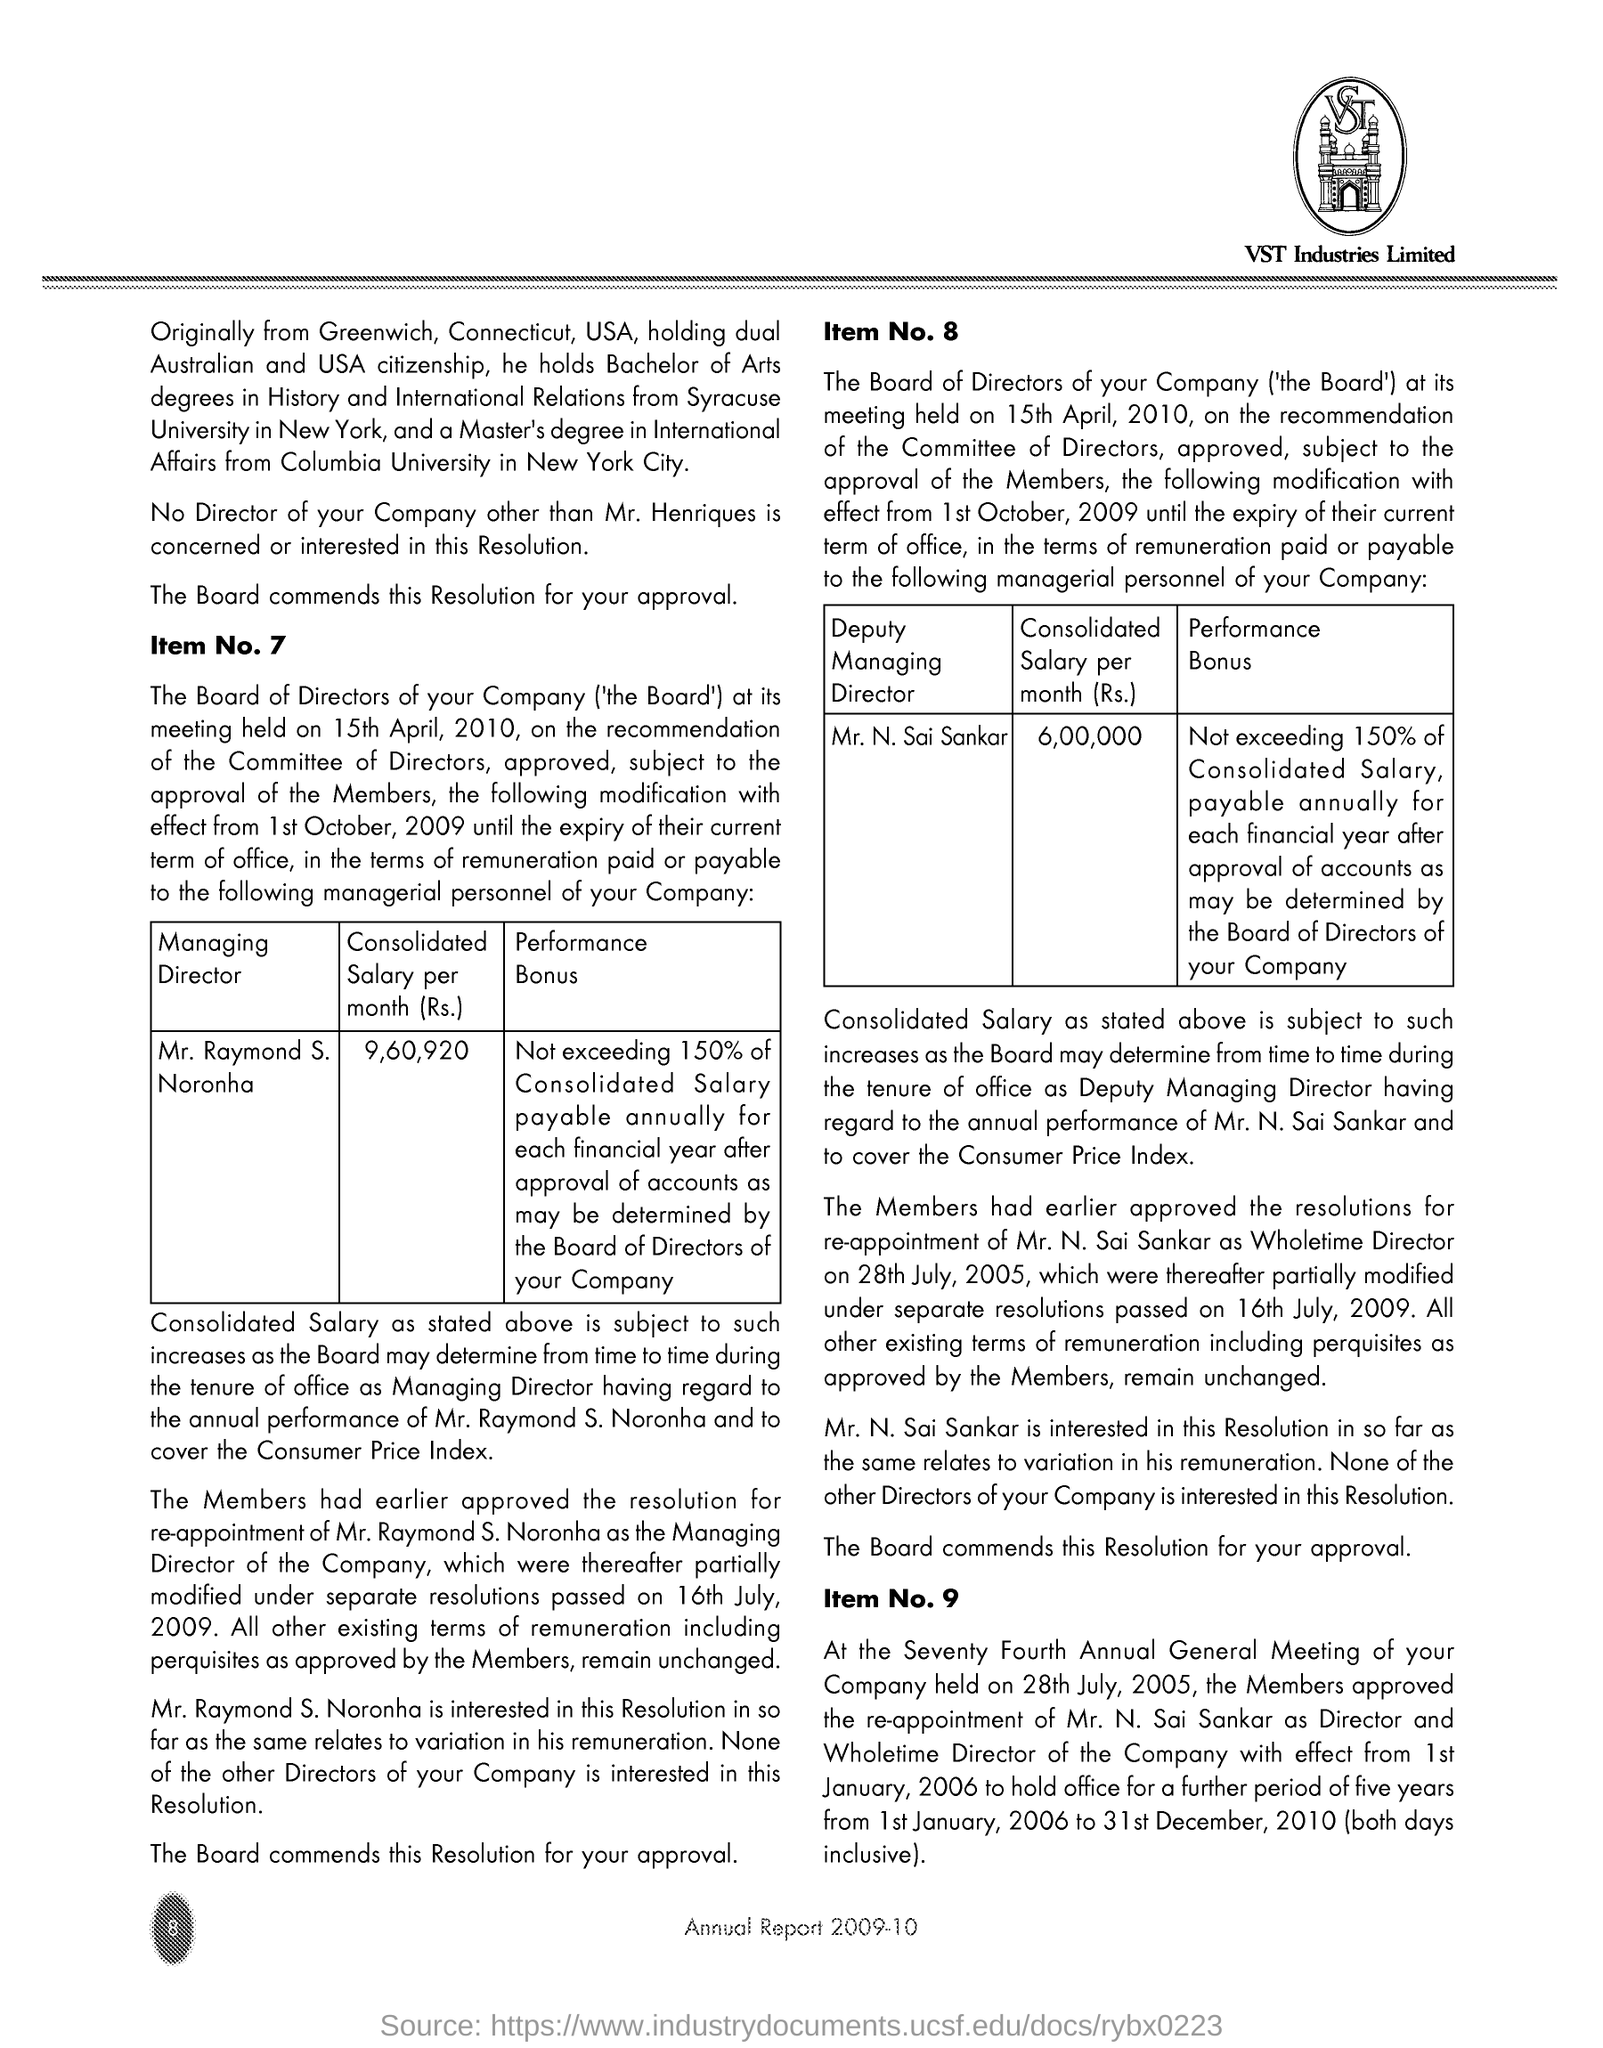What is the consolidated salary of Mr. Raymond S Norantha?
Offer a very short reply. 9,60,920. 